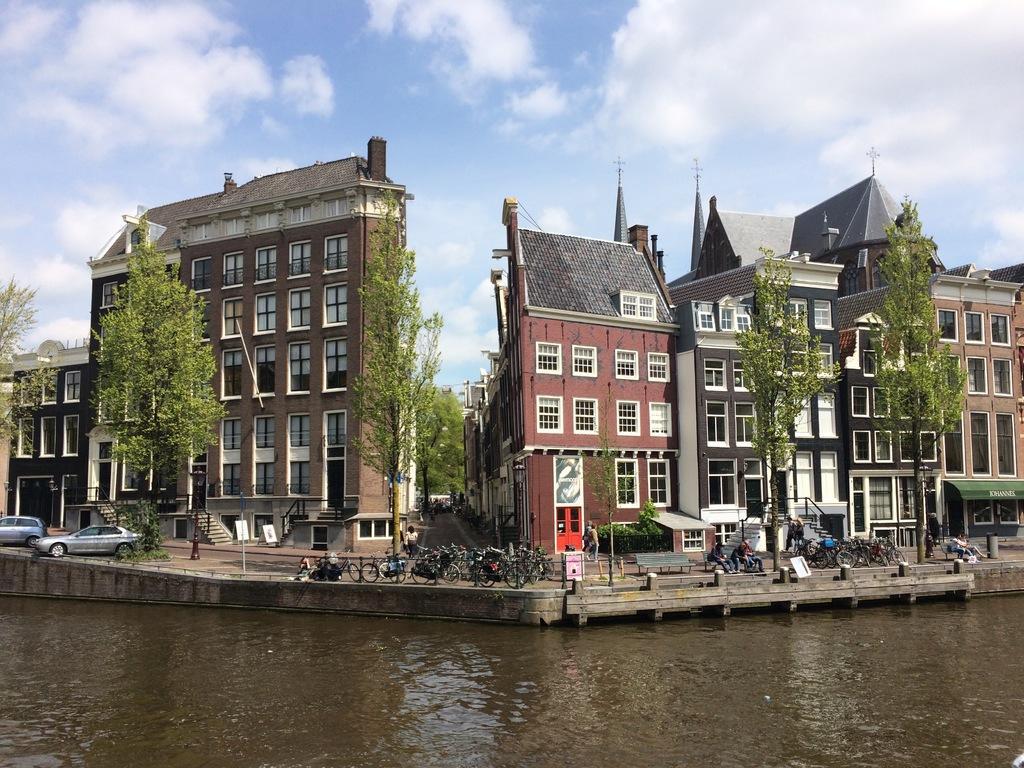How would you summarize this image in a sentence or two? In this picture we can see some buildings here, on the left side there are two cars, we can see bicycles here, at the bottom there is water, we can see trees here, there are two persons sitting on a bench, we can see the sky at the top of the picture, there are some stairs here, we can see glass windows of this building. 